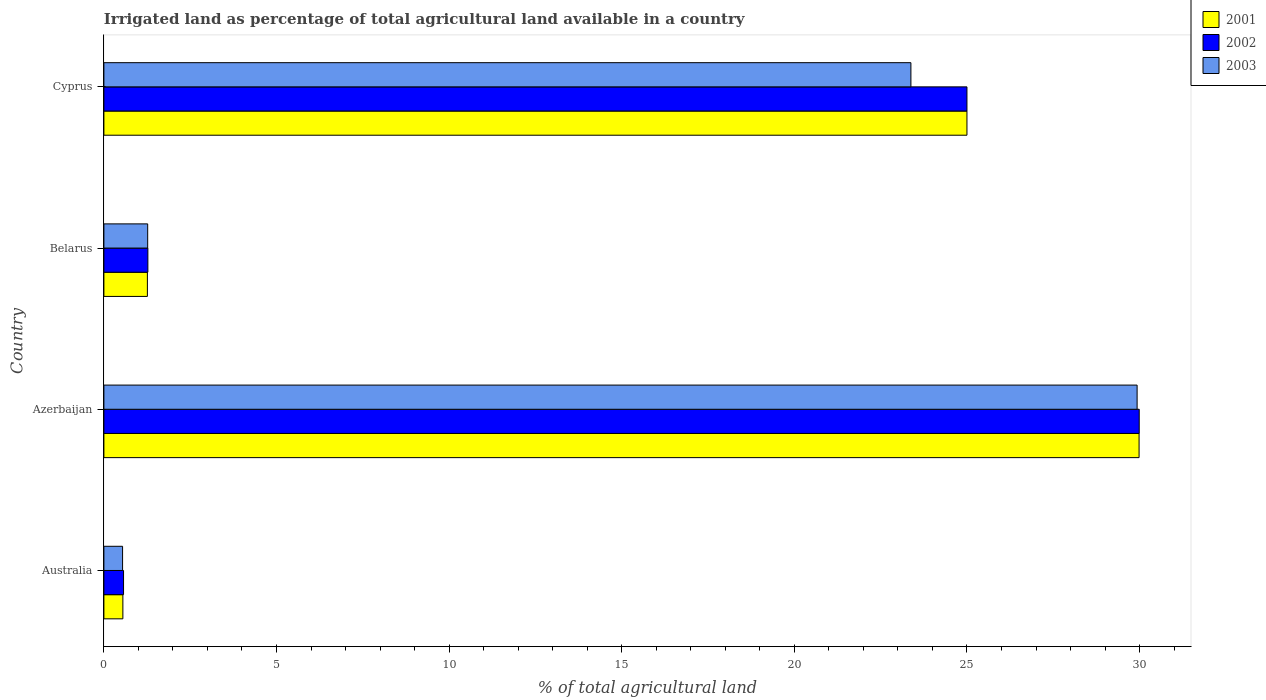Are the number of bars per tick equal to the number of legend labels?
Offer a very short reply. Yes. How many bars are there on the 1st tick from the top?
Your answer should be compact. 3. How many bars are there on the 3rd tick from the bottom?
Your answer should be very brief. 3. What is the percentage of irrigated land in 2003 in Azerbaijan?
Offer a very short reply. 29.93. Across all countries, what is the maximum percentage of irrigated land in 2003?
Provide a short and direct response. 29.93. Across all countries, what is the minimum percentage of irrigated land in 2003?
Your answer should be very brief. 0.54. In which country was the percentage of irrigated land in 2001 maximum?
Give a very brief answer. Azerbaijan. In which country was the percentage of irrigated land in 2002 minimum?
Ensure brevity in your answer.  Australia. What is the total percentage of irrigated land in 2001 in the graph?
Your answer should be compact. 56.8. What is the difference between the percentage of irrigated land in 2001 in Australia and that in Belarus?
Give a very brief answer. -0.71. What is the difference between the percentage of irrigated land in 2003 in Belarus and the percentage of irrigated land in 2001 in Australia?
Keep it short and to the point. 0.72. What is the average percentage of irrigated land in 2002 per country?
Ensure brevity in your answer.  14.21. What is the difference between the percentage of irrigated land in 2002 and percentage of irrigated land in 2001 in Australia?
Keep it short and to the point. 0.02. What is the ratio of the percentage of irrigated land in 2001 in Australia to that in Belarus?
Your answer should be very brief. 0.44. Is the difference between the percentage of irrigated land in 2002 in Australia and Azerbaijan greater than the difference between the percentage of irrigated land in 2001 in Australia and Azerbaijan?
Ensure brevity in your answer.  Yes. What is the difference between the highest and the second highest percentage of irrigated land in 2002?
Keep it short and to the point. 4.99. What is the difference between the highest and the lowest percentage of irrigated land in 2003?
Provide a succinct answer. 29.39. What does the 3rd bar from the top in Australia represents?
Your response must be concise. 2001. What does the 3rd bar from the bottom in Australia represents?
Your answer should be compact. 2003. Is it the case that in every country, the sum of the percentage of irrigated land in 2002 and percentage of irrigated land in 2001 is greater than the percentage of irrigated land in 2003?
Offer a very short reply. Yes. Are all the bars in the graph horizontal?
Offer a very short reply. Yes. What is the difference between two consecutive major ticks on the X-axis?
Offer a terse response. 5. Does the graph contain any zero values?
Your answer should be very brief. No. How are the legend labels stacked?
Your answer should be very brief. Vertical. What is the title of the graph?
Offer a terse response. Irrigated land as percentage of total agricultural land available in a country. Does "1997" appear as one of the legend labels in the graph?
Give a very brief answer. No. What is the label or title of the X-axis?
Offer a very short reply. % of total agricultural land. What is the % of total agricultural land in 2001 in Australia?
Give a very brief answer. 0.55. What is the % of total agricultural land in 2002 in Australia?
Offer a very short reply. 0.57. What is the % of total agricultural land in 2003 in Australia?
Your answer should be compact. 0.54. What is the % of total agricultural land of 2001 in Azerbaijan?
Offer a terse response. 29.99. What is the % of total agricultural land in 2002 in Azerbaijan?
Your answer should be compact. 29.99. What is the % of total agricultural land of 2003 in Azerbaijan?
Your answer should be very brief. 29.93. What is the % of total agricultural land in 2001 in Belarus?
Your answer should be compact. 1.26. What is the % of total agricultural land in 2002 in Belarus?
Provide a short and direct response. 1.27. What is the % of total agricultural land of 2003 in Belarus?
Ensure brevity in your answer.  1.27. What is the % of total agricultural land of 2003 in Cyprus?
Offer a very short reply. 23.38. Across all countries, what is the maximum % of total agricultural land in 2001?
Provide a short and direct response. 29.99. Across all countries, what is the maximum % of total agricultural land in 2002?
Offer a very short reply. 29.99. Across all countries, what is the maximum % of total agricultural land of 2003?
Offer a terse response. 29.93. Across all countries, what is the minimum % of total agricultural land in 2001?
Keep it short and to the point. 0.55. Across all countries, what is the minimum % of total agricultural land of 2002?
Offer a very short reply. 0.57. Across all countries, what is the minimum % of total agricultural land of 2003?
Your response must be concise. 0.54. What is the total % of total agricultural land of 2001 in the graph?
Give a very brief answer. 56.8. What is the total % of total agricultural land of 2002 in the graph?
Your response must be concise. 56.83. What is the total % of total agricultural land of 2003 in the graph?
Keep it short and to the point. 55.12. What is the difference between the % of total agricultural land of 2001 in Australia and that in Azerbaijan?
Ensure brevity in your answer.  -29.44. What is the difference between the % of total agricultural land of 2002 in Australia and that in Azerbaijan?
Make the answer very short. -29.42. What is the difference between the % of total agricultural land in 2003 in Australia and that in Azerbaijan?
Give a very brief answer. -29.39. What is the difference between the % of total agricultural land of 2001 in Australia and that in Belarus?
Your answer should be very brief. -0.71. What is the difference between the % of total agricultural land of 2002 in Australia and that in Belarus?
Keep it short and to the point. -0.7. What is the difference between the % of total agricultural land of 2003 in Australia and that in Belarus?
Provide a short and direct response. -0.73. What is the difference between the % of total agricultural land in 2001 in Australia and that in Cyprus?
Your answer should be very brief. -24.45. What is the difference between the % of total agricultural land in 2002 in Australia and that in Cyprus?
Your response must be concise. -24.43. What is the difference between the % of total agricultural land of 2003 in Australia and that in Cyprus?
Your response must be concise. -22.84. What is the difference between the % of total agricultural land in 2001 in Azerbaijan and that in Belarus?
Make the answer very short. 28.73. What is the difference between the % of total agricultural land of 2002 in Azerbaijan and that in Belarus?
Keep it short and to the point. 28.72. What is the difference between the % of total agricultural land of 2003 in Azerbaijan and that in Belarus?
Your response must be concise. 28.66. What is the difference between the % of total agricultural land of 2001 in Azerbaijan and that in Cyprus?
Provide a succinct answer. 4.99. What is the difference between the % of total agricultural land of 2002 in Azerbaijan and that in Cyprus?
Keep it short and to the point. 4.99. What is the difference between the % of total agricultural land in 2003 in Azerbaijan and that in Cyprus?
Offer a very short reply. 6.55. What is the difference between the % of total agricultural land in 2001 in Belarus and that in Cyprus?
Your response must be concise. -23.74. What is the difference between the % of total agricultural land in 2002 in Belarus and that in Cyprus?
Provide a succinct answer. -23.73. What is the difference between the % of total agricultural land in 2003 in Belarus and that in Cyprus?
Provide a short and direct response. -22.11. What is the difference between the % of total agricultural land of 2001 in Australia and the % of total agricultural land of 2002 in Azerbaijan?
Offer a terse response. -29.44. What is the difference between the % of total agricultural land of 2001 in Australia and the % of total agricultural land of 2003 in Azerbaijan?
Ensure brevity in your answer.  -29.38. What is the difference between the % of total agricultural land in 2002 in Australia and the % of total agricultural land in 2003 in Azerbaijan?
Offer a very short reply. -29.36. What is the difference between the % of total agricultural land in 2001 in Australia and the % of total agricultural land in 2002 in Belarus?
Make the answer very short. -0.72. What is the difference between the % of total agricultural land of 2001 in Australia and the % of total agricultural land of 2003 in Belarus?
Your answer should be very brief. -0.72. What is the difference between the % of total agricultural land in 2002 in Australia and the % of total agricultural land in 2003 in Belarus?
Your answer should be compact. -0.7. What is the difference between the % of total agricultural land of 2001 in Australia and the % of total agricultural land of 2002 in Cyprus?
Offer a terse response. -24.45. What is the difference between the % of total agricultural land of 2001 in Australia and the % of total agricultural land of 2003 in Cyprus?
Give a very brief answer. -22.83. What is the difference between the % of total agricultural land of 2002 in Australia and the % of total agricultural land of 2003 in Cyprus?
Your answer should be very brief. -22.81. What is the difference between the % of total agricultural land of 2001 in Azerbaijan and the % of total agricultural land of 2002 in Belarus?
Make the answer very short. 28.71. What is the difference between the % of total agricultural land in 2001 in Azerbaijan and the % of total agricultural land in 2003 in Belarus?
Offer a terse response. 28.72. What is the difference between the % of total agricultural land of 2002 in Azerbaijan and the % of total agricultural land of 2003 in Belarus?
Provide a succinct answer. 28.72. What is the difference between the % of total agricultural land of 2001 in Azerbaijan and the % of total agricultural land of 2002 in Cyprus?
Offer a very short reply. 4.99. What is the difference between the % of total agricultural land of 2001 in Azerbaijan and the % of total agricultural land of 2003 in Cyprus?
Offer a terse response. 6.61. What is the difference between the % of total agricultural land in 2002 in Azerbaijan and the % of total agricultural land in 2003 in Cyprus?
Offer a terse response. 6.61. What is the difference between the % of total agricultural land of 2001 in Belarus and the % of total agricultural land of 2002 in Cyprus?
Ensure brevity in your answer.  -23.74. What is the difference between the % of total agricultural land of 2001 in Belarus and the % of total agricultural land of 2003 in Cyprus?
Give a very brief answer. -22.12. What is the difference between the % of total agricultural land in 2002 in Belarus and the % of total agricultural land in 2003 in Cyprus?
Make the answer very short. -22.1. What is the average % of total agricultural land of 2001 per country?
Your answer should be compact. 14.2. What is the average % of total agricultural land of 2002 per country?
Offer a very short reply. 14.21. What is the average % of total agricultural land of 2003 per country?
Ensure brevity in your answer.  13.78. What is the difference between the % of total agricultural land in 2001 and % of total agricultural land in 2002 in Australia?
Offer a terse response. -0.02. What is the difference between the % of total agricultural land in 2001 and % of total agricultural land in 2003 in Australia?
Keep it short and to the point. 0.01. What is the difference between the % of total agricultural land of 2002 and % of total agricultural land of 2003 in Australia?
Your answer should be very brief. 0.03. What is the difference between the % of total agricultural land of 2001 and % of total agricultural land of 2002 in Azerbaijan?
Keep it short and to the point. -0. What is the difference between the % of total agricultural land of 2001 and % of total agricultural land of 2003 in Azerbaijan?
Keep it short and to the point. 0.06. What is the difference between the % of total agricultural land of 2002 and % of total agricultural land of 2003 in Azerbaijan?
Ensure brevity in your answer.  0.06. What is the difference between the % of total agricultural land in 2001 and % of total agricultural land in 2002 in Belarus?
Give a very brief answer. -0.01. What is the difference between the % of total agricultural land of 2001 and % of total agricultural land of 2003 in Belarus?
Offer a terse response. -0.01. What is the difference between the % of total agricultural land in 2002 and % of total agricultural land in 2003 in Belarus?
Provide a short and direct response. 0.01. What is the difference between the % of total agricultural land in 2001 and % of total agricultural land in 2003 in Cyprus?
Provide a short and direct response. 1.62. What is the difference between the % of total agricultural land of 2002 and % of total agricultural land of 2003 in Cyprus?
Make the answer very short. 1.62. What is the ratio of the % of total agricultural land in 2001 in Australia to that in Azerbaijan?
Provide a short and direct response. 0.02. What is the ratio of the % of total agricultural land of 2002 in Australia to that in Azerbaijan?
Give a very brief answer. 0.02. What is the ratio of the % of total agricultural land of 2003 in Australia to that in Azerbaijan?
Your response must be concise. 0.02. What is the ratio of the % of total agricultural land of 2001 in Australia to that in Belarus?
Keep it short and to the point. 0.44. What is the ratio of the % of total agricultural land in 2002 in Australia to that in Belarus?
Provide a short and direct response. 0.45. What is the ratio of the % of total agricultural land of 2003 in Australia to that in Belarus?
Keep it short and to the point. 0.43. What is the ratio of the % of total agricultural land of 2001 in Australia to that in Cyprus?
Provide a succinct answer. 0.02. What is the ratio of the % of total agricultural land of 2002 in Australia to that in Cyprus?
Make the answer very short. 0.02. What is the ratio of the % of total agricultural land in 2003 in Australia to that in Cyprus?
Offer a terse response. 0.02. What is the ratio of the % of total agricultural land of 2001 in Azerbaijan to that in Belarus?
Keep it short and to the point. 23.8. What is the ratio of the % of total agricultural land of 2002 in Azerbaijan to that in Belarus?
Offer a very short reply. 23.54. What is the ratio of the % of total agricultural land of 2003 in Azerbaijan to that in Belarus?
Give a very brief answer. 23.59. What is the ratio of the % of total agricultural land of 2001 in Azerbaijan to that in Cyprus?
Provide a short and direct response. 1.2. What is the ratio of the % of total agricultural land of 2002 in Azerbaijan to that in Cyprus?
Your response must be concise. 1.2. What is the ratio of the % of total agricultural land of 2003 in Azerbaijan to that in Cyprus?
Give a very brief answer. 1.28. What is the ratio of the % of total agricultural land in 2001 in Belarus to that in Cyprus?
Offer a very short reply. 0.05. What is the ratio of the % of total agricultural land of 2002 in Belarus to that in Cyprus?
Make the answer very short. 0.05. What is the ratio of the % of total agricultural land in 2003 in Belarus to that in Cyprus?
Provide a short and direct response. 0.05. What is the difference between the highest and the second highest % of total agricultural land in 2001?
Your answer should be very brief. 4.99. What is the difference between the highest and the second highest % of total agricultural land in 2002?
Provide a short and direct response. 4.99. What is the difference between the highest and the second highest % of total agricultural land of 2003?
Offer a very short reply. 6.55. What is the difference between the highest and the lowest % of total agricultural land in 2001?
Offer a very short reply. 29.44. What is the difference between the highest and the lowest % of total agricultural land of 2002?
Give a very brief answer. 29.42. What is the difference between the highest and the lowest % of total agricultural land of 2003?
Ensure brevity in your answer.  29.39. 